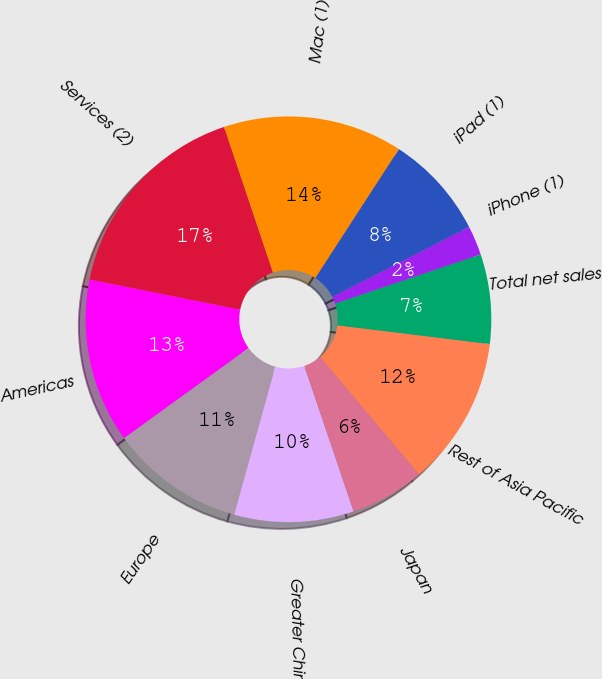Convert chart. <chart><loc_0><loc_0><loc_500><loc_500><pie_chart><fcel>Americas<fcel>Europe<fcel>Greater China<fcel>Japan<fcel>Rest of Asia Pacific<fcel>Total net sales<fcel>iPhone (1)<fcel>iPad (1)<fcel>Mac (1)<fcel>Services (2)<nl><fcel>13.11%<fcel>10.72%<fcel>9.52%<fcel>5.93%<fcel>11.92%<fcel>7.13%<fcel>2.34%<fcel>8.32%<fcel>14.31%<fcel>16.7%<nl></chart> 